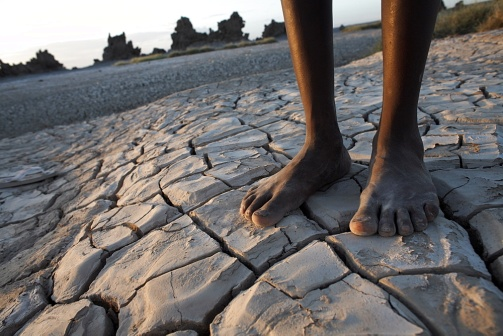What might this image symbolize or represent? This image can symbolize the theme of survival and human resilience in the face of environmental adversity. The feet standing firm on cracked earth can be seen as a metaphor for overcoming difficulties, highlighting the human capacity to endure and adapt to harsh circumstances. 